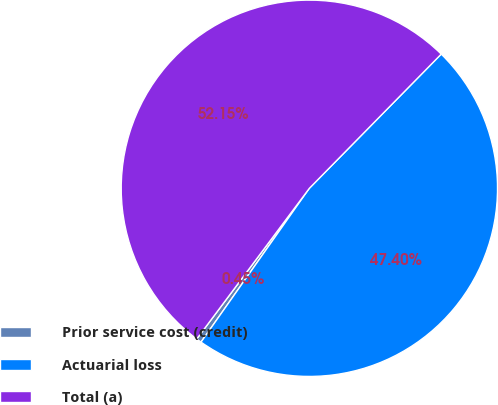Convert chart to OTSL. <chart><loc_0><loc_0><loc_500><loc_500><pie_chart><fcel>Prior service cost (credit)<fcel>Actuarial loss<fcel>Total (a)<nl><fcel>0.45%<fcel>47.4%<fcel>52.14%<nl></chart> 